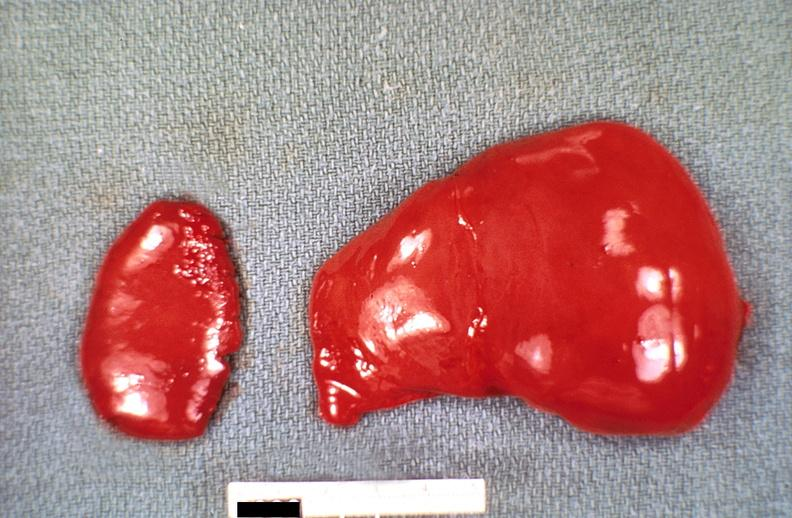what is present?
Answer the question using a single word or phrase. Hepatobiliary 